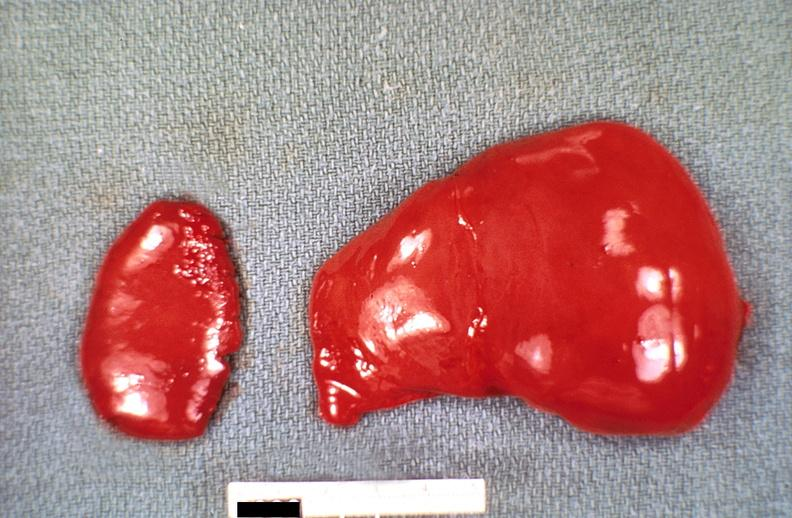what is present?
Answer the question using a single word or phrase. Hepatobiliary 